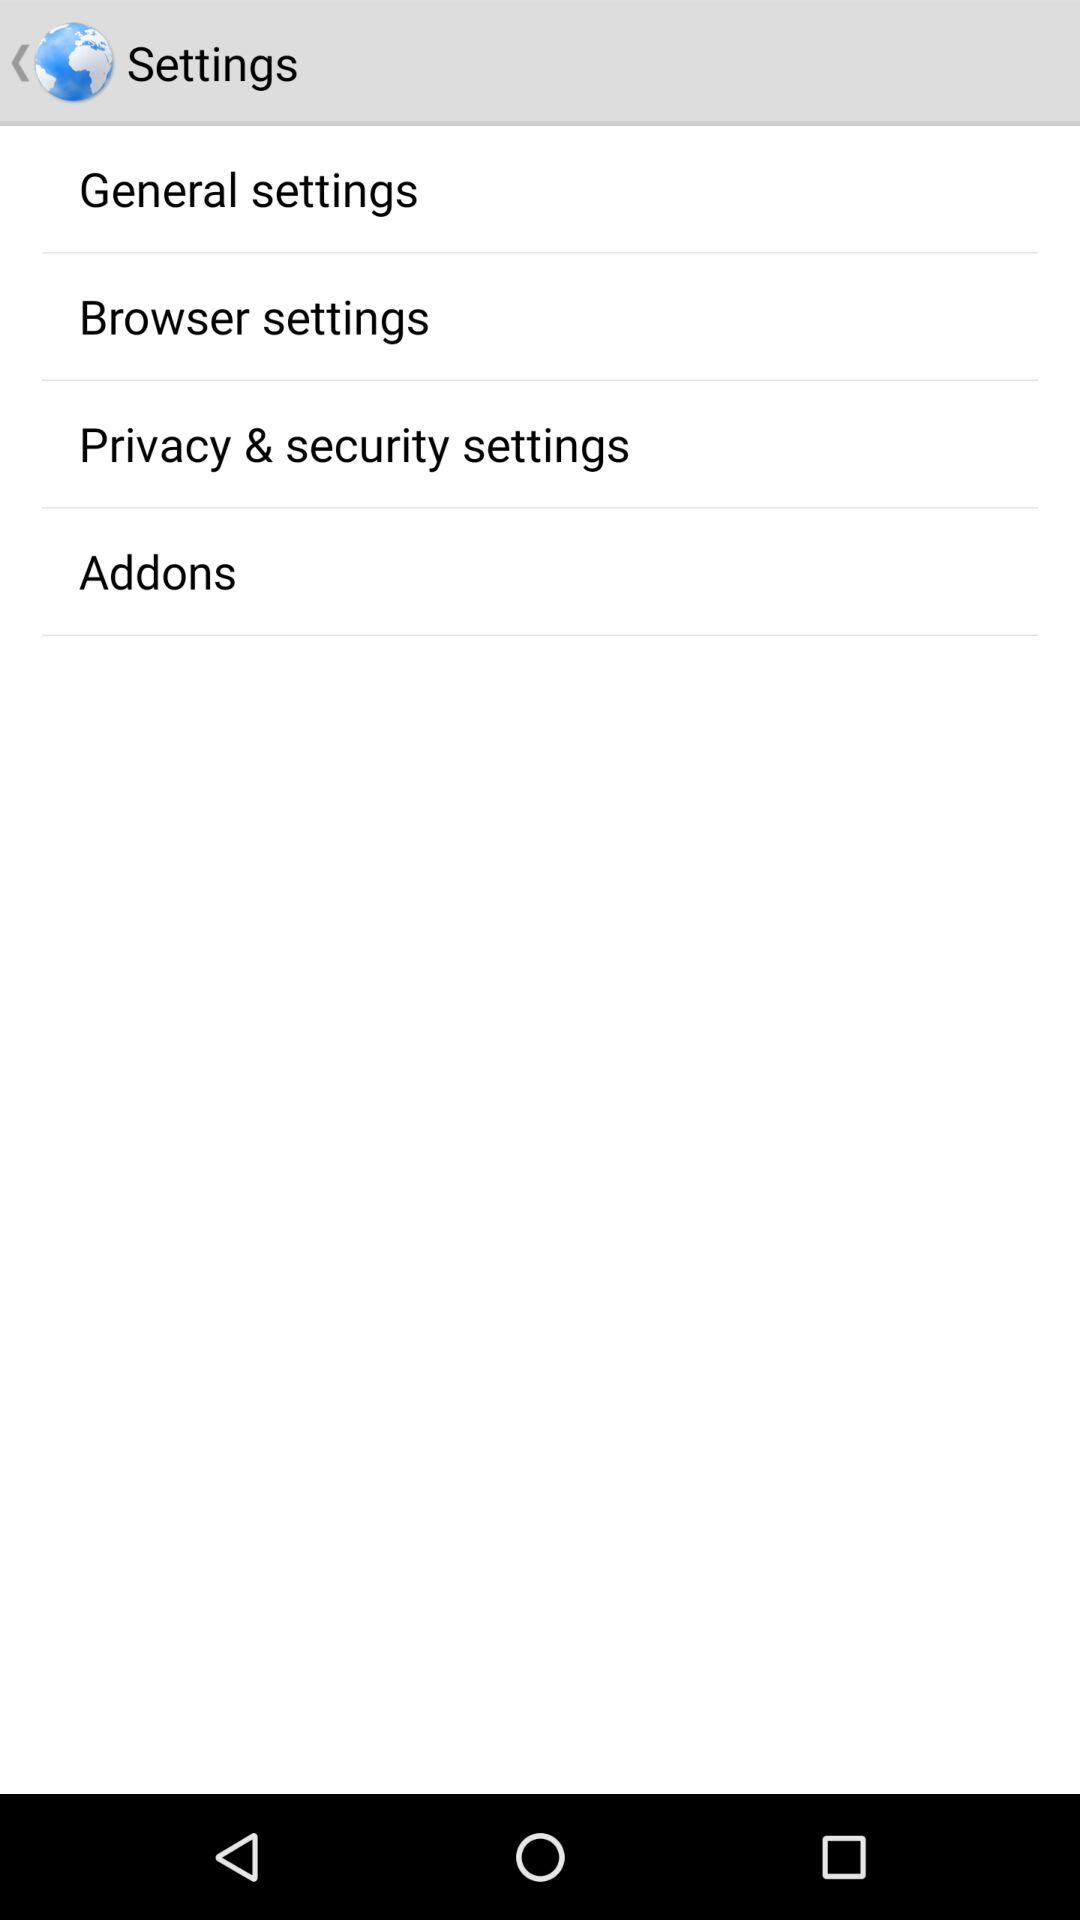How many settings are there in total?
Answer the question using a single word or phrase. 4 